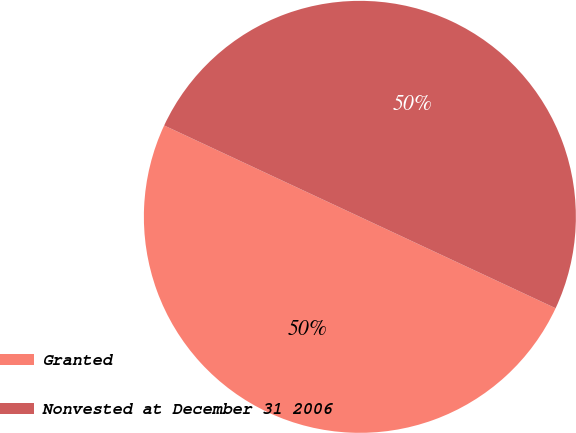<chart> <loc_0><loc_0><loc_500><loc_500><pie_chart><fcel>Granted<fcel>Nonvested at December 31 2006<nl><fcel>50.0%<fcel>50.0%<nl></chart> 